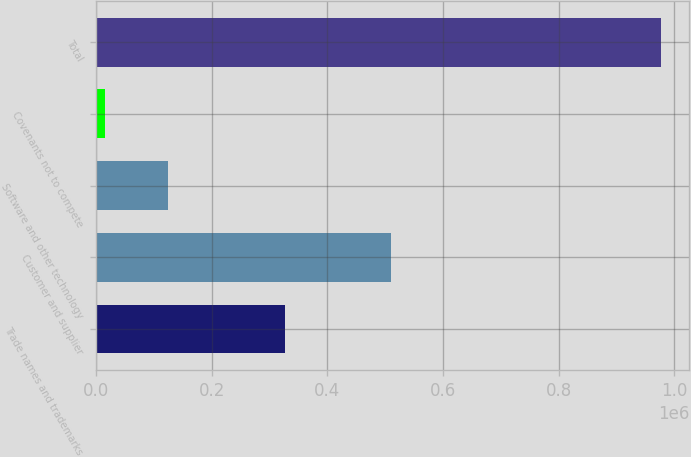<chart> <loc_0><loc_0><loc_500><loc_500><bar_chart><fcel>Trade names and trademarks<fcel>Customer and supplier<fcel>Software and other technology<fcel>Covenants not to compete<fcel>Total<nl><fcel>327332<fcel>510113<fcel>124049<fcel>14981<fcel>976475<nl></chart> 